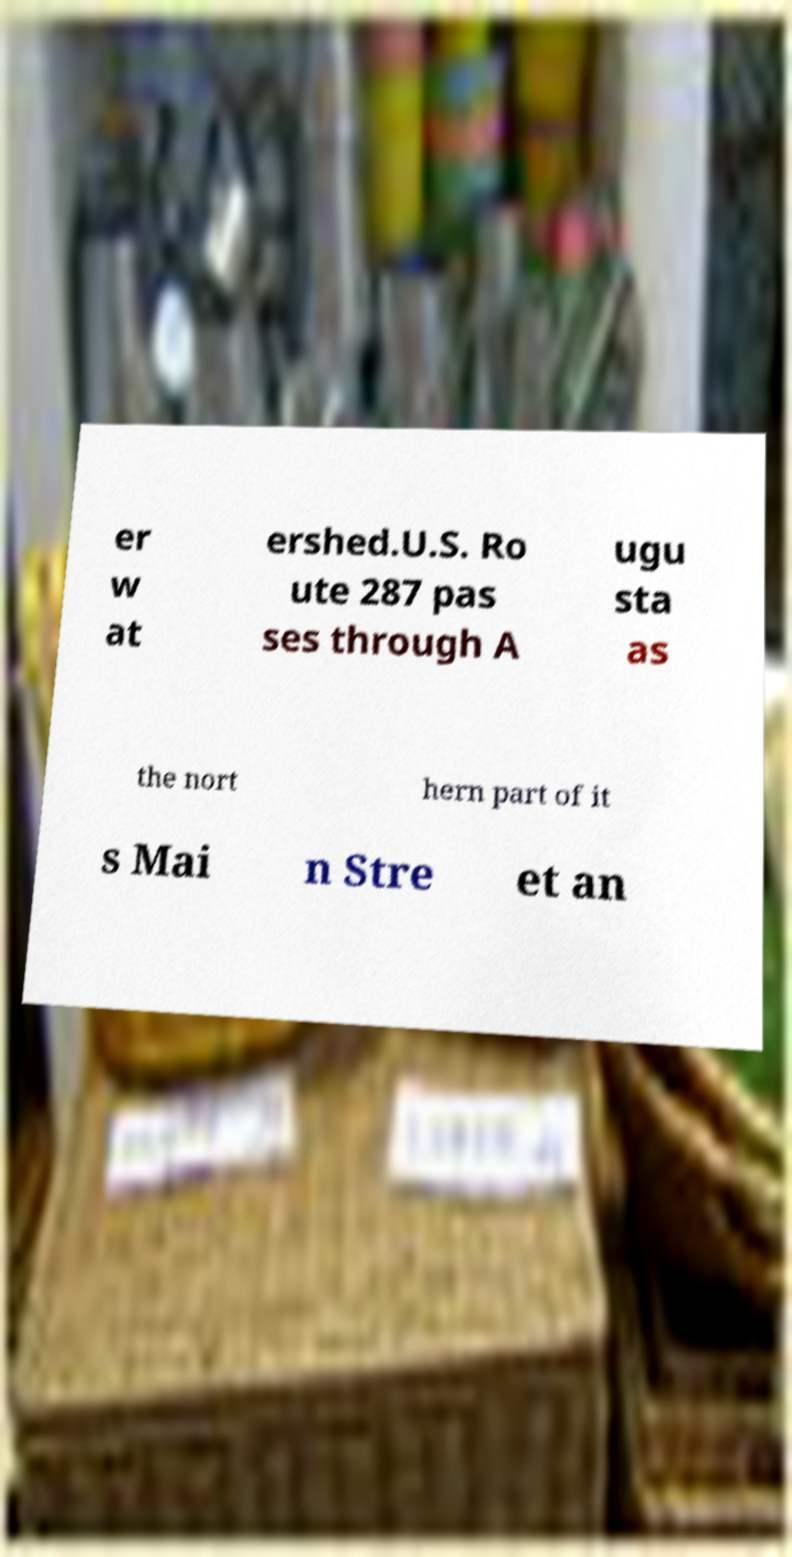Can you accurately transcribe the text from the provided image for me? er w at ershed.U.S. Ro ute 287 pas ses through A ugu sta as the nort hern part of it s Mai n Stre et an 